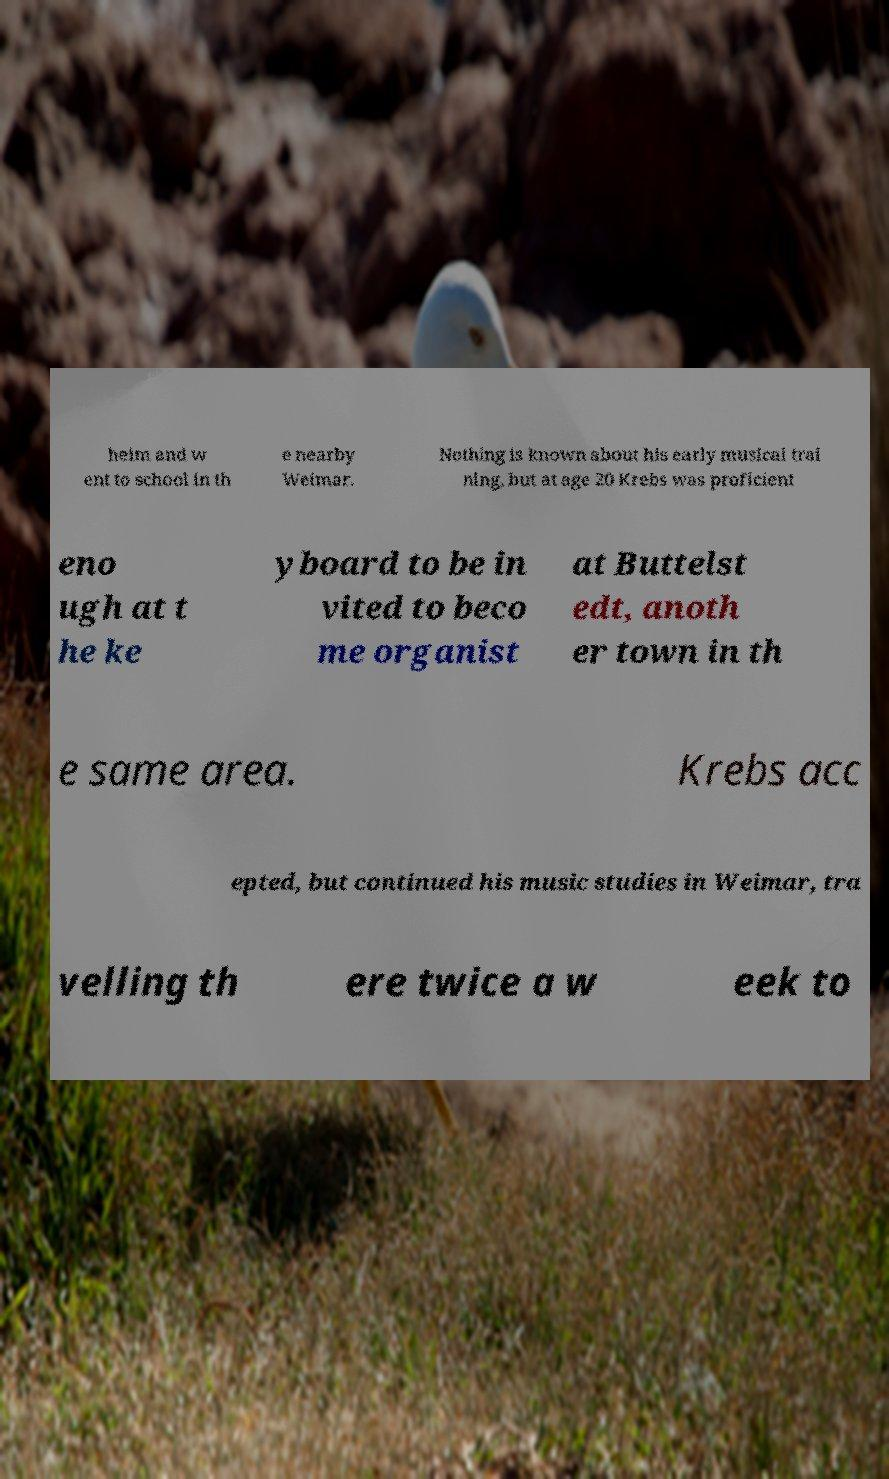Could you extract and type out the text from this image? heim and w ent to school in th e nearby Weimar. Nothing is known about his early musical trai ning, but at age 20 Krebs was proficient eno ugh at t he ke yboard to be in vited to beco me organist at Buttelst edt, anoth er town in th e same area. Krebs acc epted, but continued his music studies in Weimar, tra velling th ere twice a w eek to 